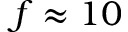<formula> <loc_0><loc_0><loc_500><loc_500>f \approx 1 0</formula> 